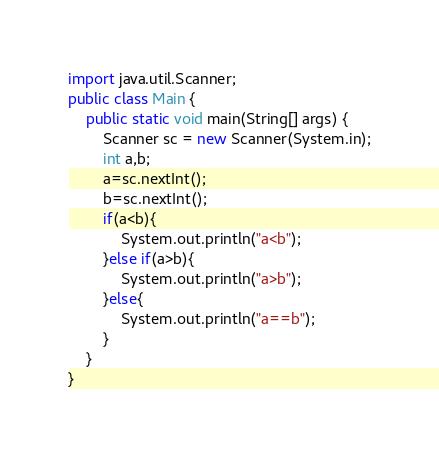Convert code to text. <code><loc_0><loc_0><loc_500><loc_500><_Java_>import java.util.Scanner;
public class Main {
	public static void main(String[] args) {
		Scanner sc = new Scanner(System.in);
		int a,b;
		a=sc.nextInt();
		b=sc.nextInt();
		if(a<b){
			System.out.println("a<b");
		}else if(a>b){
			System.out.println("a>b");
		}else{
			System.out.println("a==b");
		}
	}
}</code> 